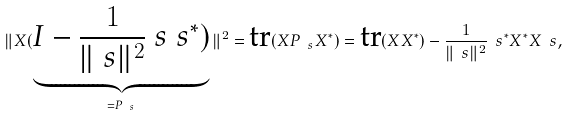<formula> <loc_0><loc_0><loc_500><loc_500>\| X ( \underbrace { I - \frac { 1 } { \| \ s \| ^ { 2 } } \ s \ s ^ { * } ) } _ { = P _ { \ s } } \| ^ { 2 } = \text {tr} ( X P _ { \ s } X ^ { * } ) = \text {tr} ( X X ^ { * } ) - \frac { 1 } { \| \ s \| ^ { 2 } } \ s ^ { * } X ^ { * } X \ s ,</formula> 